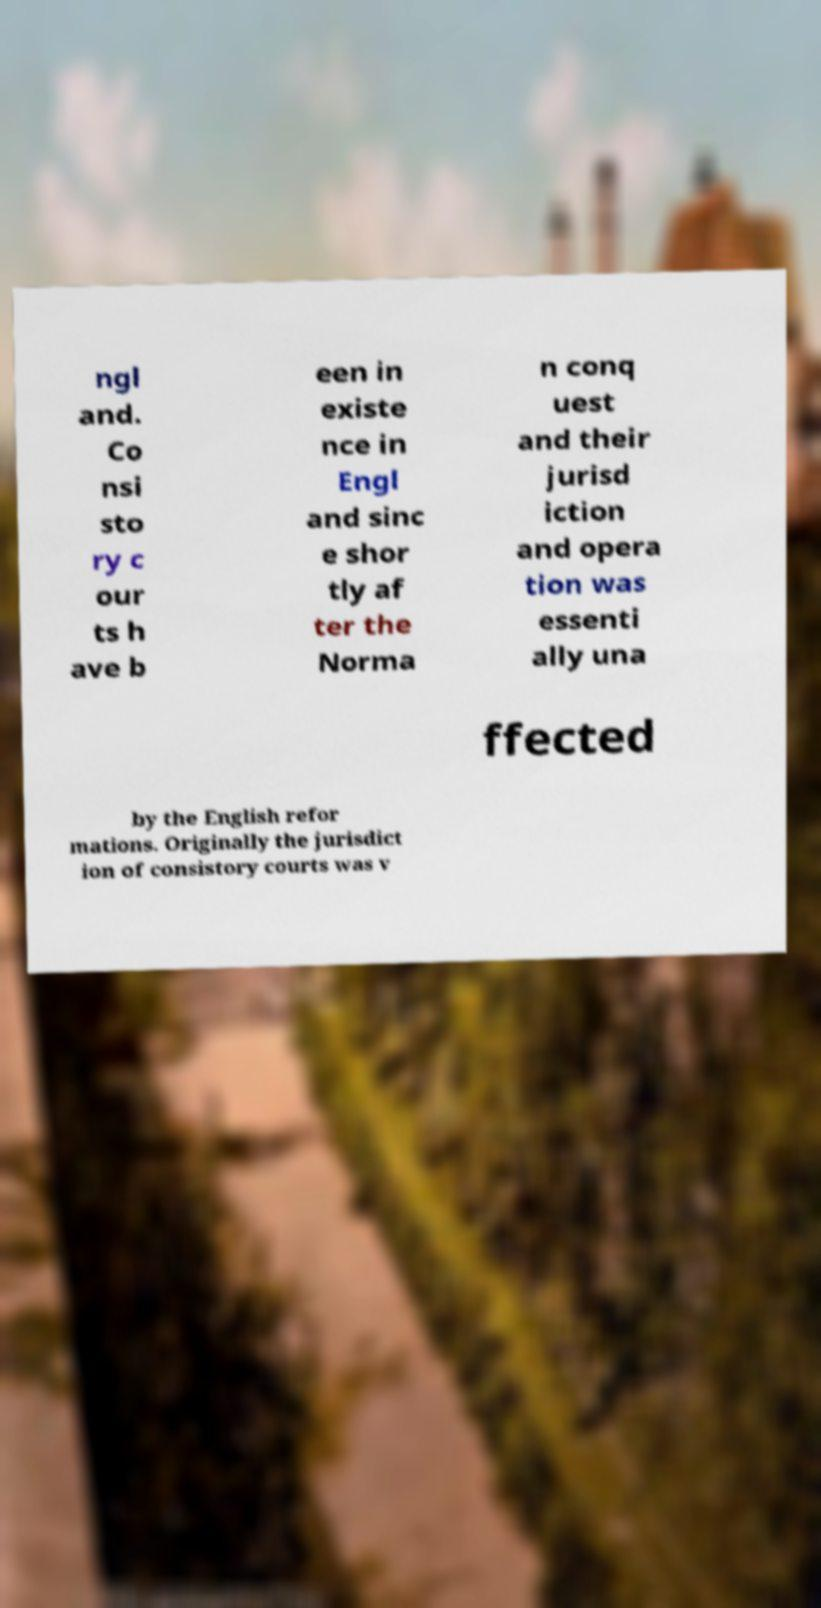What messages or text are displayed in this image? I need them in a readable, typed format. ngl and. Co nsi sto ry c our ts h ave b een in existe nce in Engl and sinc e shor tly af ter the Norma n conq uest and their jurisd iction and opera tion was essenti ally una ffected by the English refor mations. Originally the jurisdict ion of consistory courts was v 